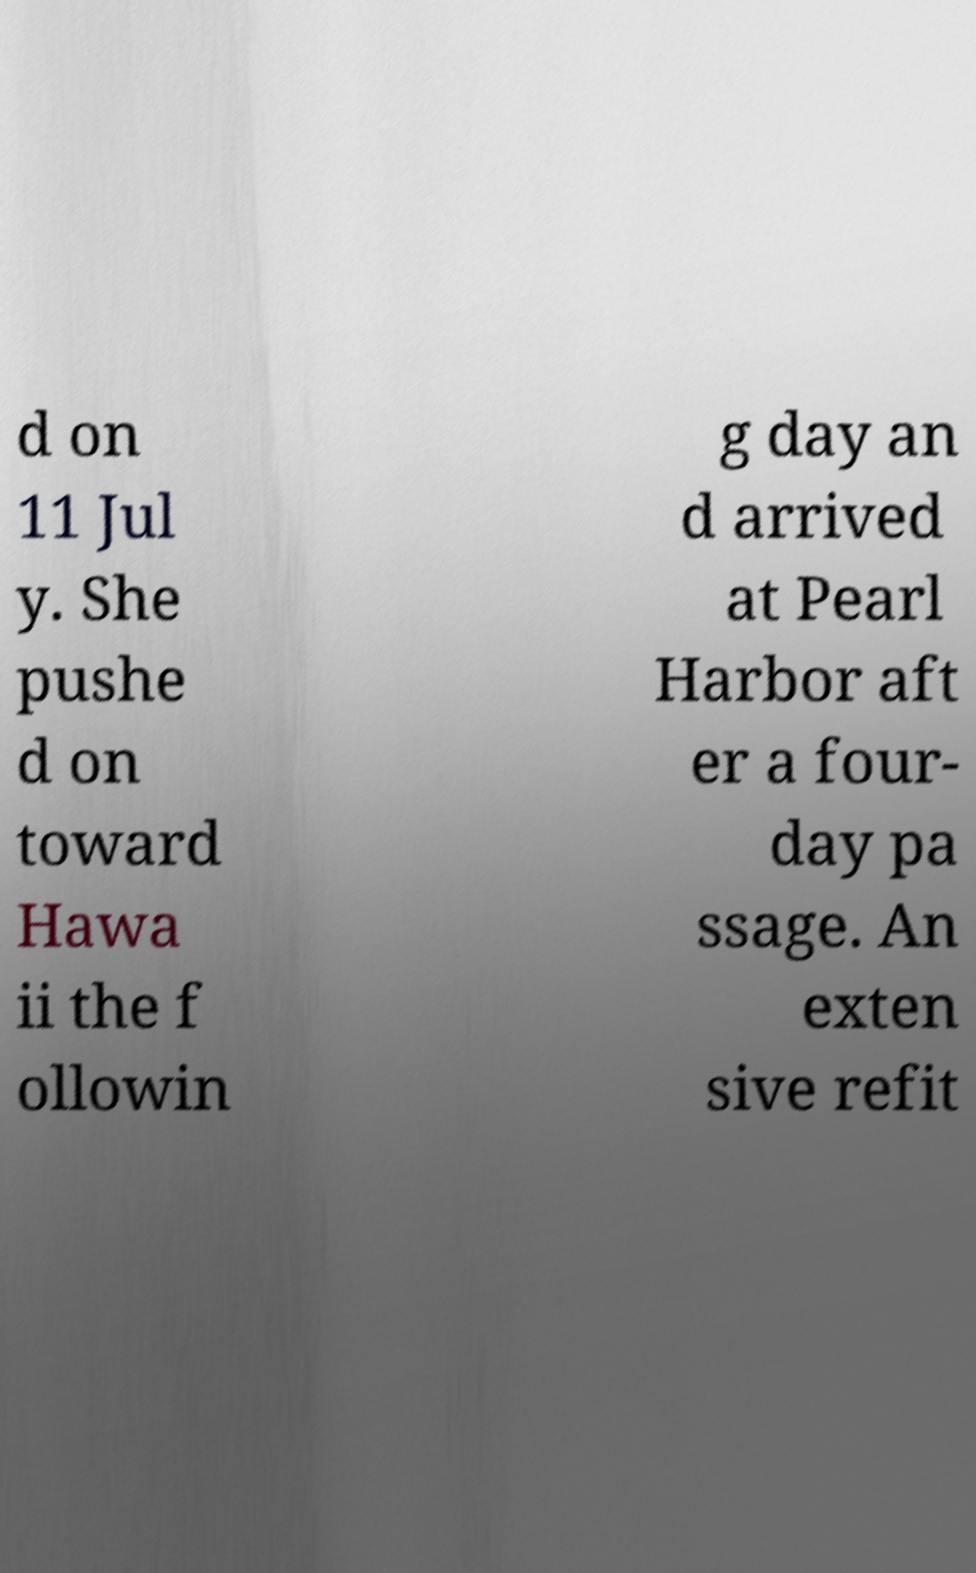Can you accurately transcribe the text from the provided image for me? d on 11 Jul y. She pushe d on toward Hawa ii the f ollowin g day an d arrived at Pearl Harbor aft er a four- day pa ssage. An exten sive refit 